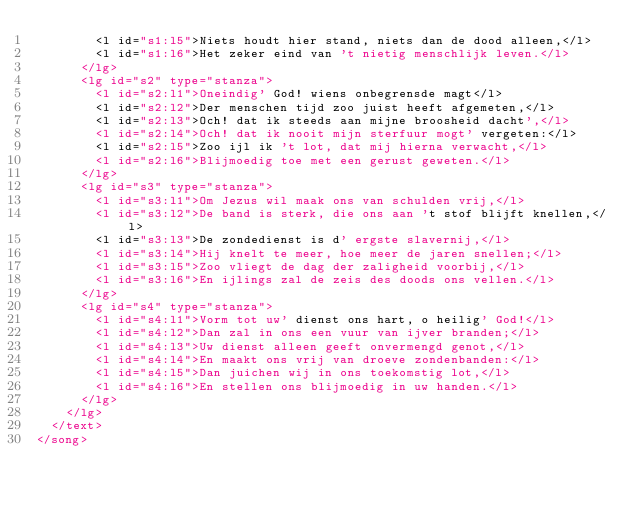Convert code to text. <code><loc_0><loc_0><loc_500><loc_500><_XML_>        <l id="s1:l5">Niets houdt hier stand, niets dan de dood alleen,</l>
        <l id="s1:l6">Het zeker eind van 't nietig menschlijk leven.</l>
      </lg>
      <lg id="s2" type="stanza">
        <l id="s2:l1">Oneindig' God! wiens onbegrensde magt</l>
        <l id="s2:l2">Der menschen tijd zoo juist heeft afgemeten,</l>
        <l id="s2:l3">Och! dat ik steeds aan mijne broosheid dacht',</l>
        <l id="s2:l4">Och! dat ik nooit mijn sterfuur mogt' vergeten:</l>
        <l id="s2:l5">Zoo ijl ik 't lot, dat mij hierna verwacht,</l>
        <l id="s2:l6">Blijmoedig toe met een gerust geweten.</l>
      </lg>
      <lg id="s3" type="stanza">
        <l id="s3:l1">Om Jezus wil maak ons van schulden vrij,</l>
        <l id="s3:l2">De band is sterk, die ons aan 't stof blijft knellen,</l>
        <l id="s3:l3">De zondedienst is d' ergste slavernij,</l>
        <l id="s3:l4">Hij knelt te meer, hoe meer de jaren snellen;</l>
        <l id="s3:l5">Zoo vliegt de dag der zaligheid voorbij,</l>
        <l id="s3:l6">En ijlings zal de zeis des doods ons vellen.</l>
      </lg>
      <lg id="s4" type="stanza">
        <l id="s4:l1">Vorm tot uw' dienst ons hart, o heilig' God!</l>
        <l id="s4:l2">Dan zal in ons een vuur van ijver branden;</l>
        <l id="s4:l3">Uw dienst alleen geeft onvermengd genot,</l>
        <l id="s4:l4">En maakt ons vrij van droeve zondenbanden:</l>
        <l id="s4:l5">Dan juichen wij in ons toekomstig lot,</l>
        <l id="s4:l6">En stellen ons blijmoedig in uw handen.</l>
      </lg>
    </lg>
  </text>
</song>
</code> 